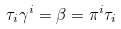<formula> <loc_0><loc_0><loc_500><loc_500>\tau _ { i } \gamma ^ { i } = \beta = \pi ^ { i } \tau _ { i }</formula> 